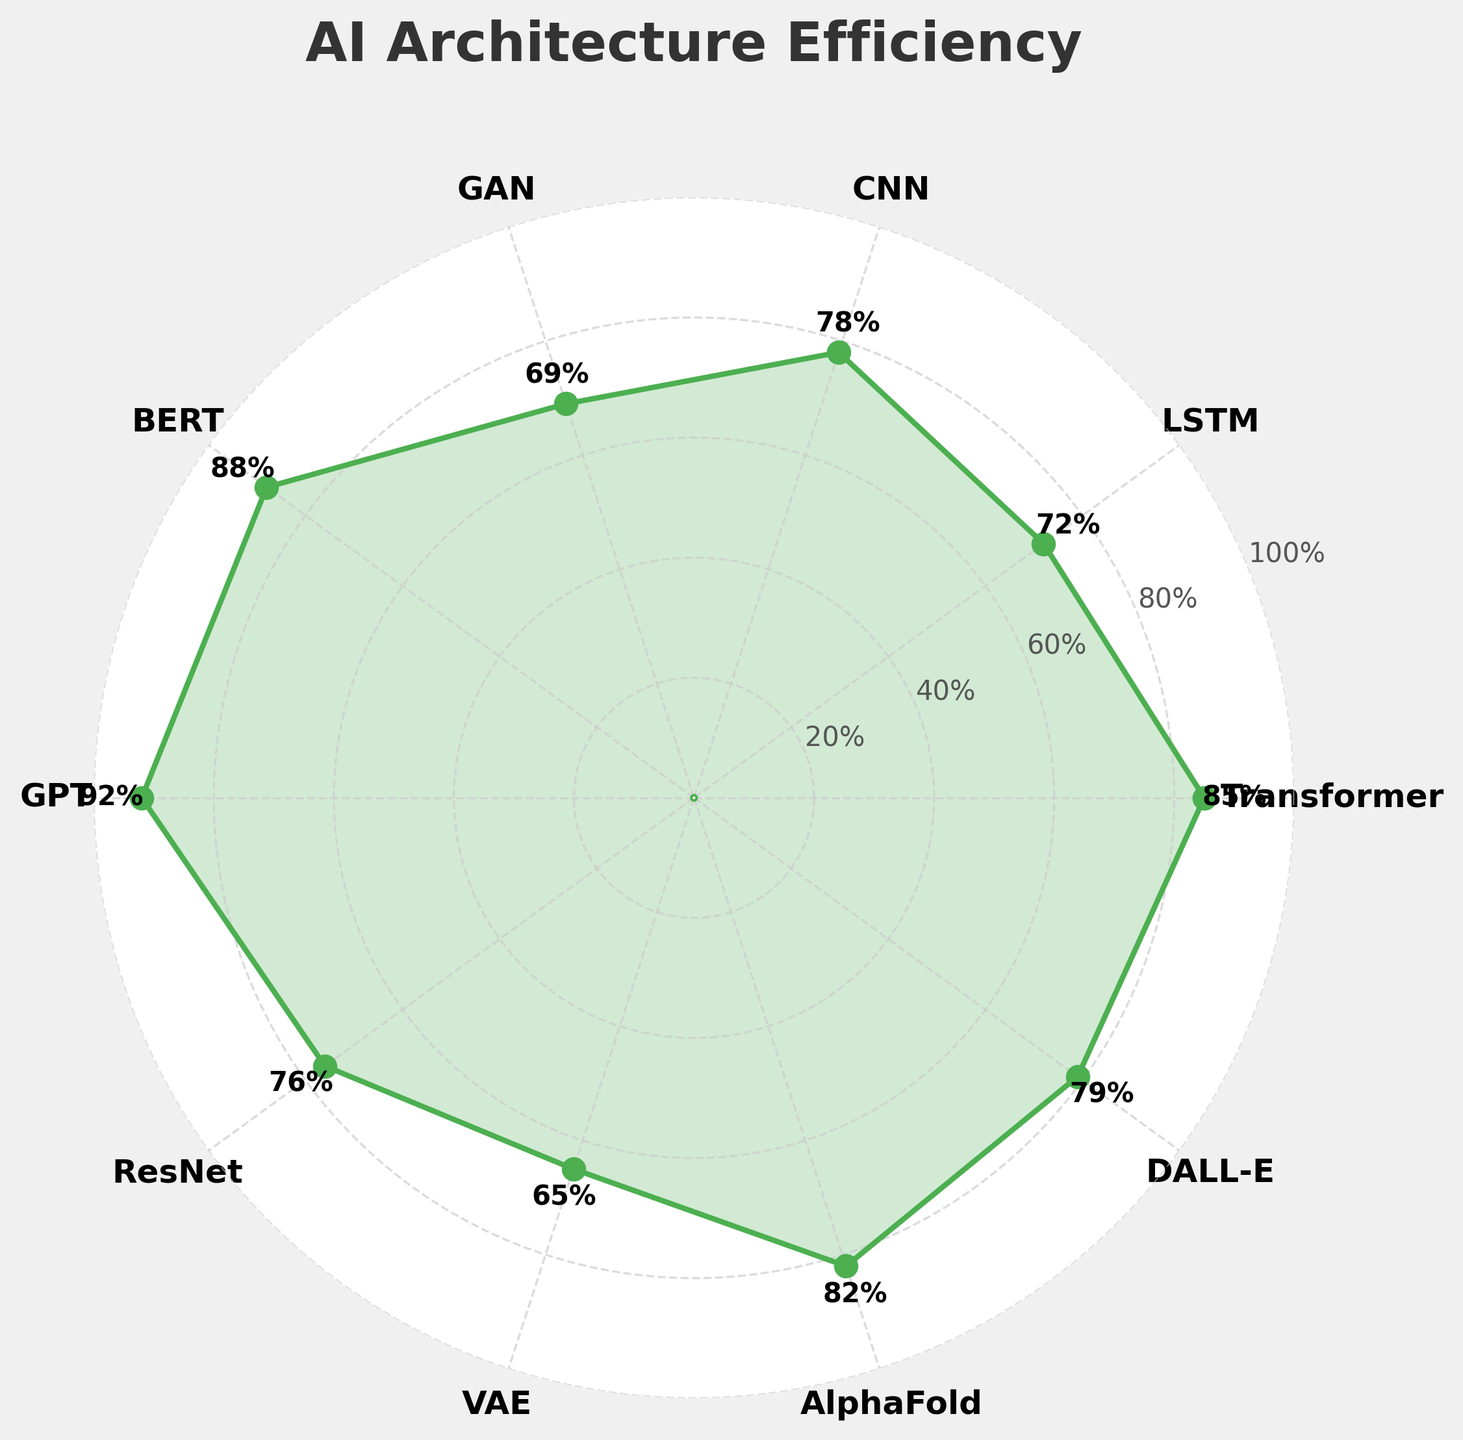What's the maximum efficiency percentage shown in the figure? To find the maximum efficiency percentage, look at all the efficiency values associated with each AI architecture. The highest value is the maximum efficiency percentage.
Answer: 92% Which AI architecture has the lowest computational resource utilization efficiency? Examine the efficiency values for each AI architecture. The architecture with the lowest value is the one with the lowest efficiency.
Answer: VAE What is the average efficiency percentage across all AI architectures shown? Add up all the efficiency percentages and divide by the total number of architectures. The sum of the efficiencies is 786, and there are 10 architectures. So, 786 / 10 = 78.6
Answer: 78.6% How does the efficiency of GPT compare to that of BERT? Compare the efficiency percentages of GPT and BERT directly. GPT has an efficiency of 92%, and BERT has 88%.
Answer: GPT is more efficient Which two AI architectures have efficiencies closest to the average efficiency of all architectures? First, calculate the average efficiency, which is 78.6%. Then, find the efficiencies closest to this average: CNN (78) and DALL-E (79) are the closest.
Answer: CNN and DALL-E Which AI architecture shows an efficiency increase from LSTM? Compare LSTM's efficiency (72%) with other architectures. Transformer (85%), BERT (88%), GPT (92%), ResNet (76%), AlphaFold (82%), and DALL-E (79%) all have greater efficiencies.
Answer: Transformer, BERT, GPT, ResNet, AlphaFold, DALL-E What is the efficiency difference between the most and least efficient AI architectures? The most efficient architecture is GPT (92%) and the least efficient is VAE (65%). The difference is 92% - 65%
Answer: 27% Which AI architecture is positioned immediately following LSTM on the gauge chart? Since the figure is a circular gauge, LSTM is followed by CNN in the clockwise direction.
Answer: CNN What is the median efficiency percentage of the AI architectures? Arrange the efficiency percentages in ascending order: 65, 69, 72, 76, 78, 79, 82, 85, 88, 92. The median value is the average of the 5th and 6th values: (78 + 79) / 2 = 78.5
Answer: 78.5 